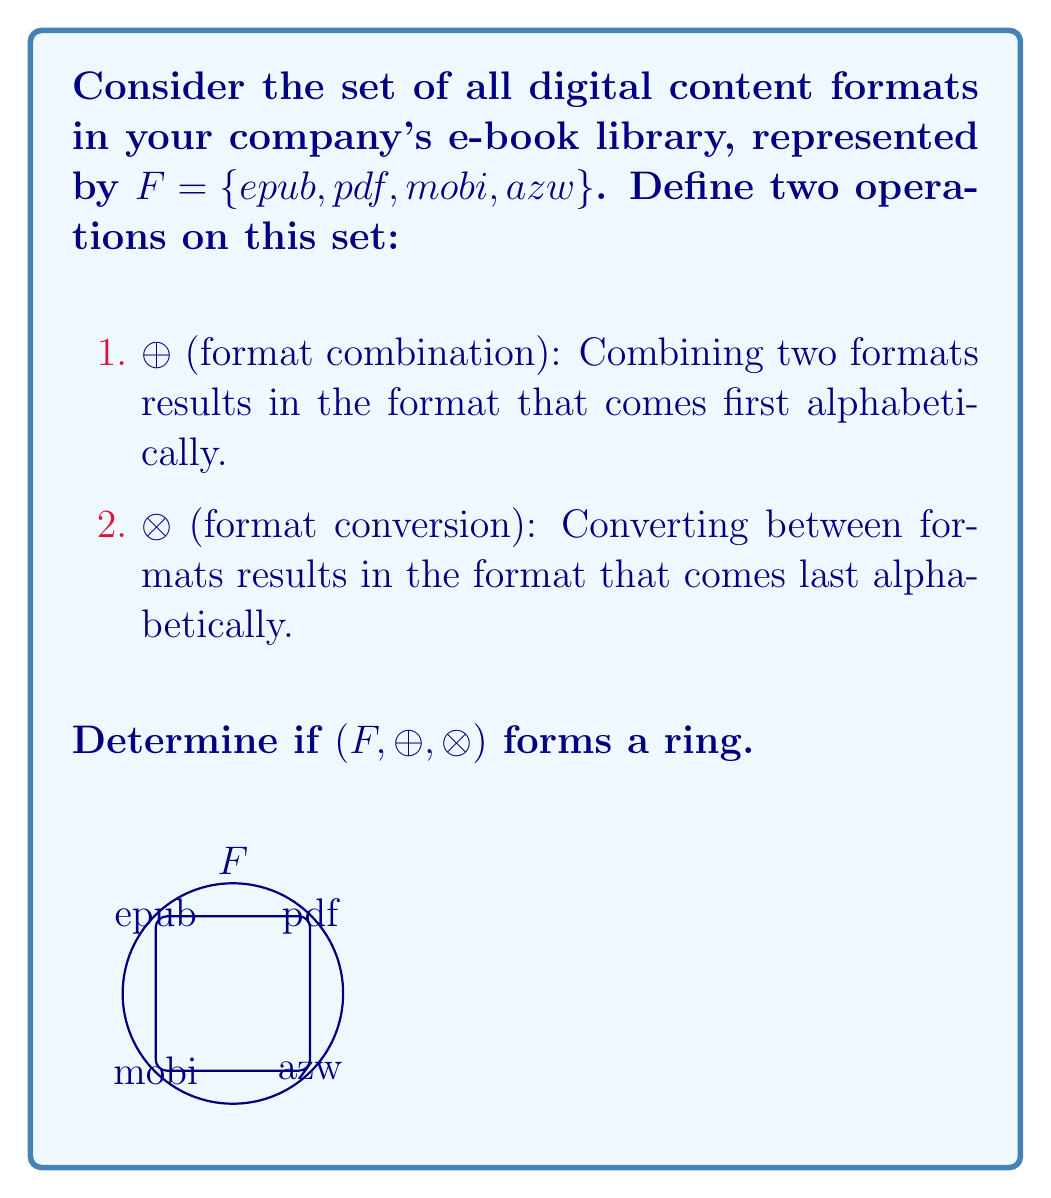Could you help me with this problem? To determine if $(F, \oplus, \otimes)$ forms a ring, we need to check if it satisfies all ring axioms:

1. $(F, \oplus)$ must be an abelian group:
   a) Closure: $\forall a,b \in F, a \oplus b \in F$ (True, always results in a format in F)
   b) Associativity: $(a \oplus b) \oplus c = a \oplus (b \oplus c)$ (True, always first alphabetically)
   c) Commutativity: $a \oplus b = b \oplus a$ (True, order doesn't matter)
   d) Identity: $\exists e \in F, a \oplus e = a$ (True, 'pdf' is the identity)
   e) Inverse: $\forall a \in F, \exists -a \in F, a \oplus (-a) = e$ (False, no inverse for 'azw', 'epub', 'mobi')

2. $(F, \otimes)$ must be a monoid:
   a) Closure: $\forall a,b \in F, a \otimes b \in F$ (True, always results in a format in F)
   b) Associativity: $(a \otimes b) \otimes c = a \otimes (b \otimes c)$ (True, always last alphabetically)
   c) Identity: $\exists e \in F, a \otimes e = a \otimes e = a$ (True, 'azw' is the identity)

3. Distributive laws:
   a) $a \otimes (b \oplus c) = (a \otimes b) \oplus (a \otimes c)$ (True)
   b) $(a \oplus b) \otimes c = (a \otimes c) \oplus (b \otimes c)$ (True)

Since $(F, \oplus)$ is not an abelian group due to the lack of inverses, $(F, \oplus, \otimes)$ does not form a ring.
Answer: No, $(F, \oplus, \otimes)$ is not a ring. 